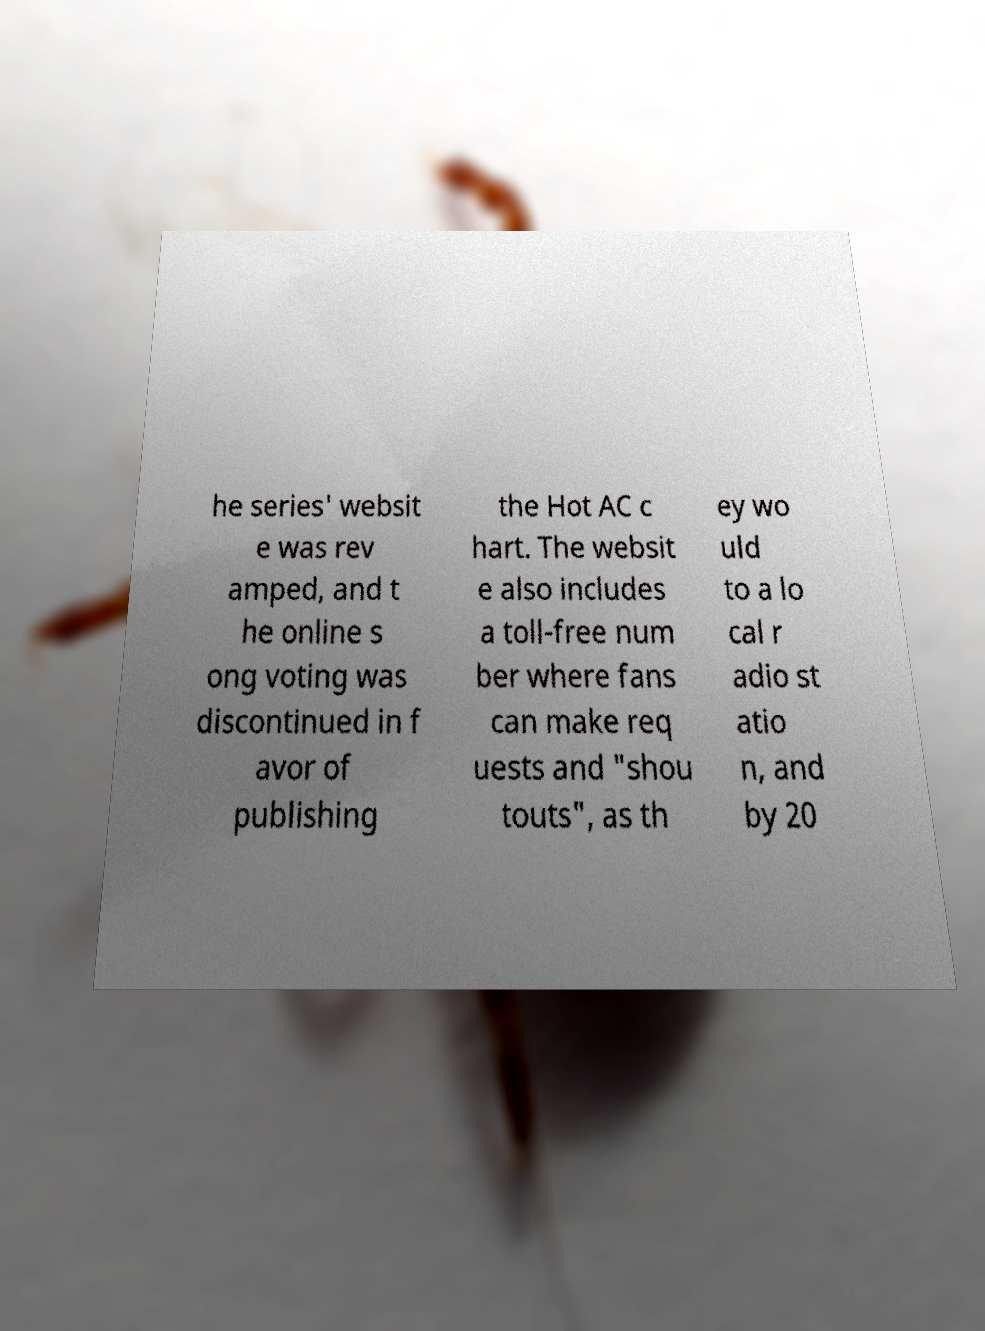Please read and relay the text visible in this image. What does it say? he series' websit e was rev amped, and t he online s ong voting was discontinued in f avor of publishing the Hot AC c hart. The websit e also includes a toll-free num ber where fans can make req uests and "shou touts", as th ey wo uld to a lo cal r adio st atio n, and by 20 